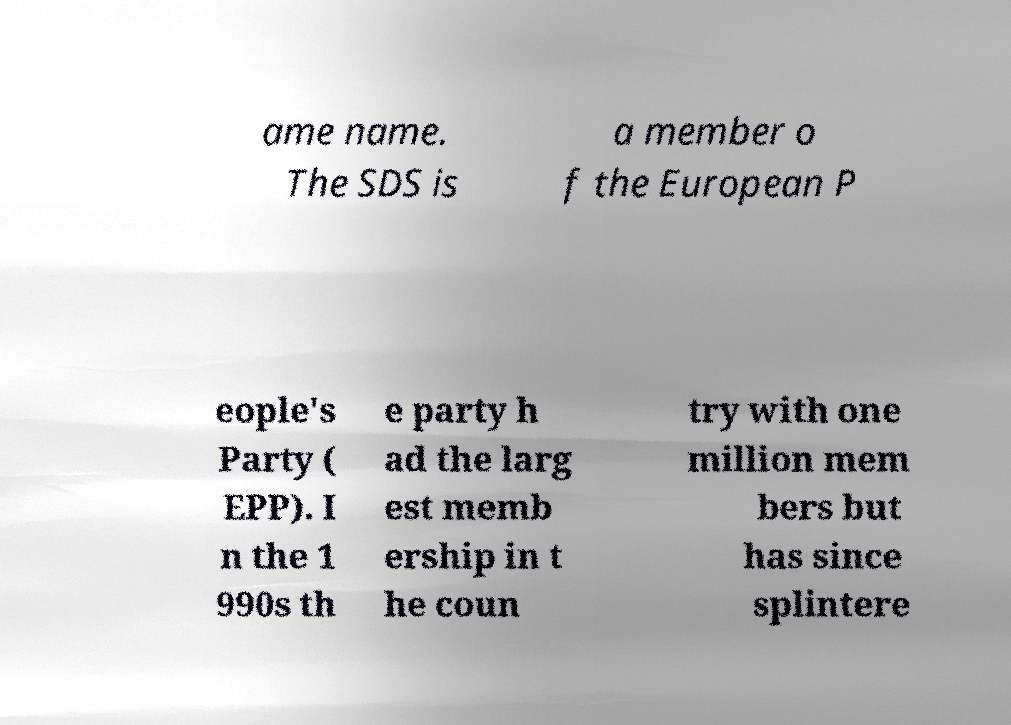Please read and relay the text visible in this image. What does it say? ame name. The SDS is a member o f the European P eople's Party ( EPP). I n the 1 990s th e party h ad the larg est memb ership in t he coun try with one million mem bers but has since splintere 